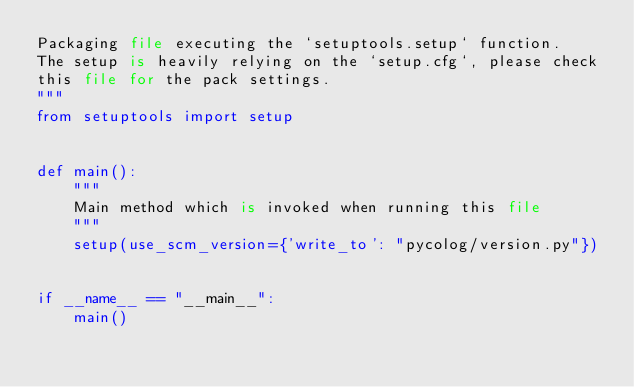Convert code to text. <code><loc_0><loc_0><loc_500><loc_500><_Python_>Packaging file executing the `setuptools.setup` function.
The setup is heavily relying on the `setup.cfg`, please check
this file for the pack settings.
"""
from setuptools import setup


def main():
    """
    Main method which is invoked when running this file
    """
    setup(use_scm_version={'write_to': "pycolog/version.py"})


if __name__ == "__main__":
    main()
</code> 